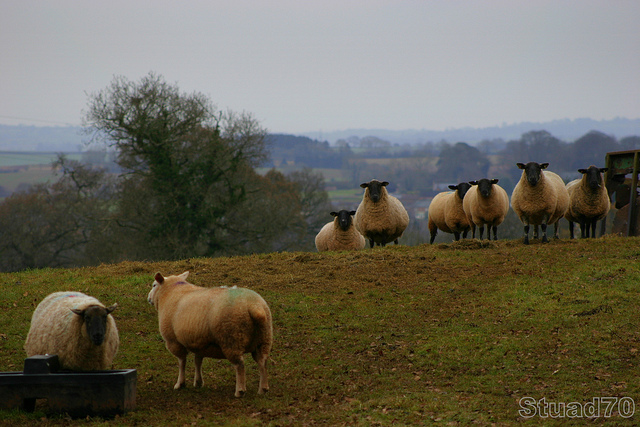Please transcribe the text information in this image. Stuad7 70 